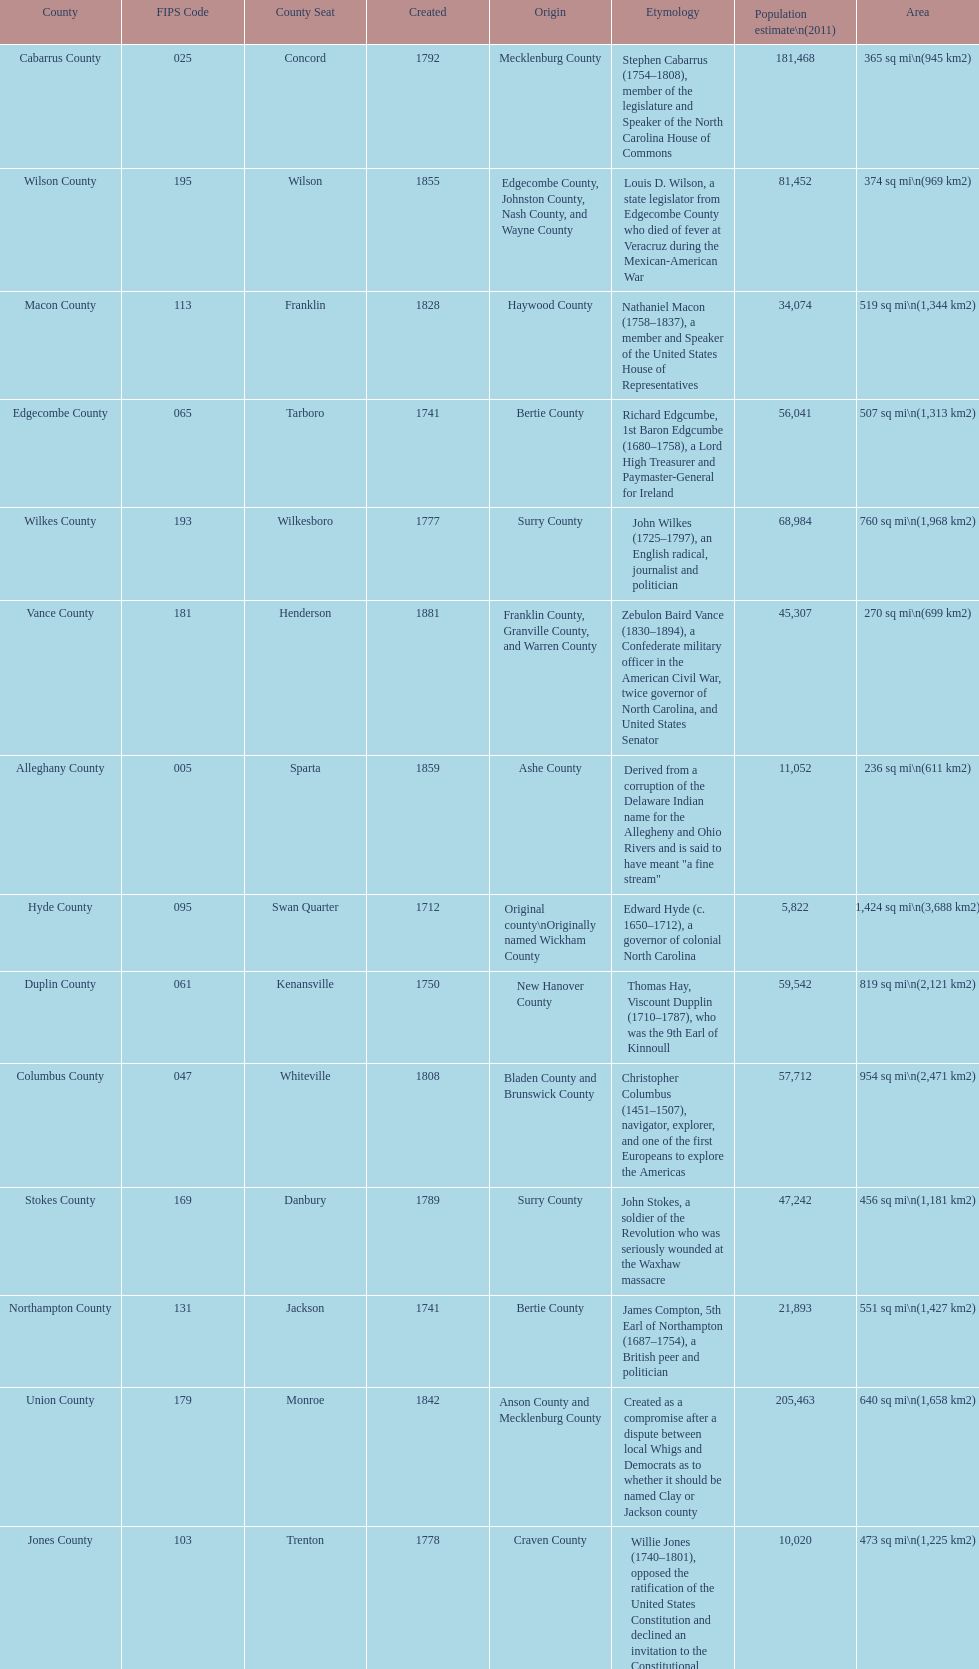What is the only county whose name comes from a battle? Alamance County. 